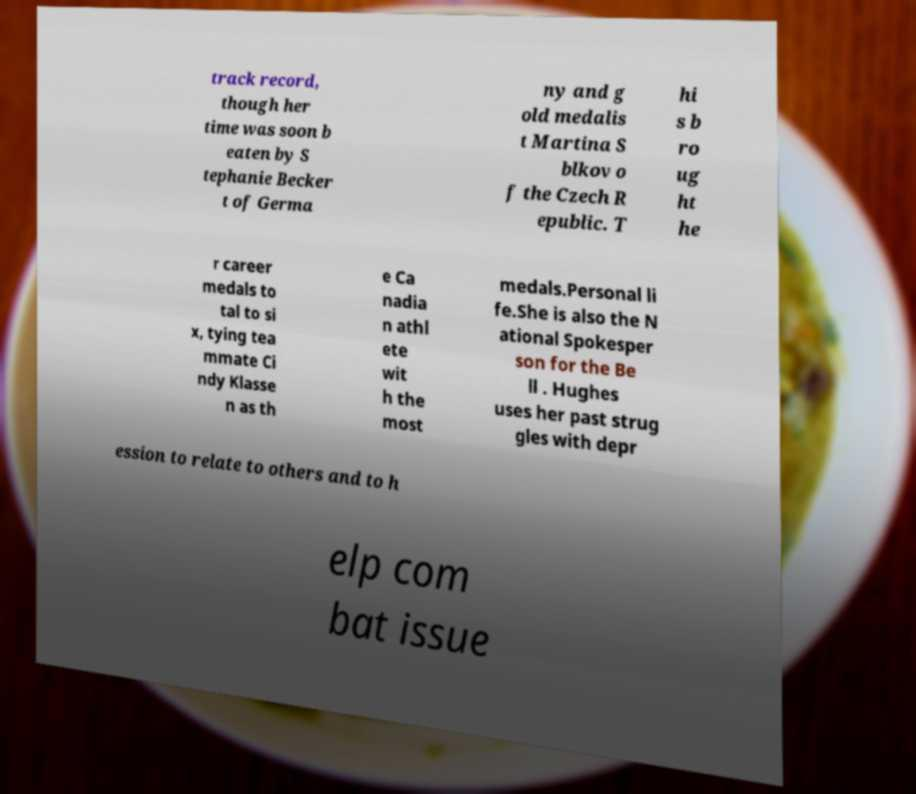For documentation purposes, I need the text within this image transcribed. Could you provide that? track record, though her time was soon b eaten by S tephanie Becker t of Germa ny and g old medalis t Martina S blkov o f the Czech R epublic. T hi s b ro ug ht he r career medals to tal to si x, tying tea mmate Ci ndy Klasse n as th e Ca nadia n athl ete wit h the most medals.Personal li fe.She is also the N ational Spokesper son for the Be ll . Hughes uses her past strug gles with depr ession to relate to others and to h elp com bat issue 